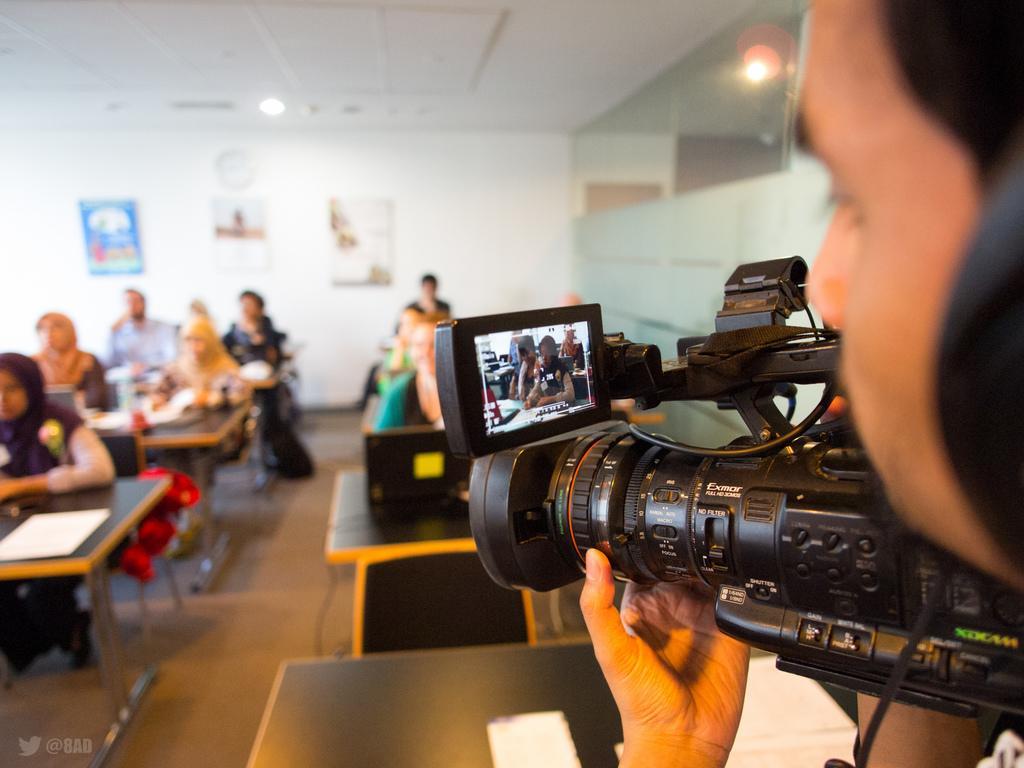Can you describe this image briefly? Right side of the image there is a person holding a camera in his hand. Left side there are few chairs and tables. Few persons are sitting on the chairs. There are few papers on the table. Few posters are attached to the wall. Few lights are attached to the roof. Middle of the image there is a laptop on the table. 